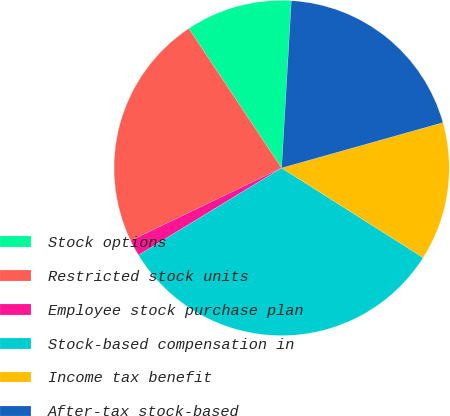Convert chart to OTSL. <chart><loc_0><loc_0><loc_500><loc_500><pie_chart><fcel>Stock options<fcel>Restricted stock units<fcel>Employee stock purchase plan<fcel>Stock-based compensation in<fcel>Income tax benefit<fcel>After-tax stock-based<nl><fcel>10.27%<fcel>22.79%<fcel>1.57%<fcel>32.31%<fcel>13.35%<fcel>19.71%<nl></chart> 